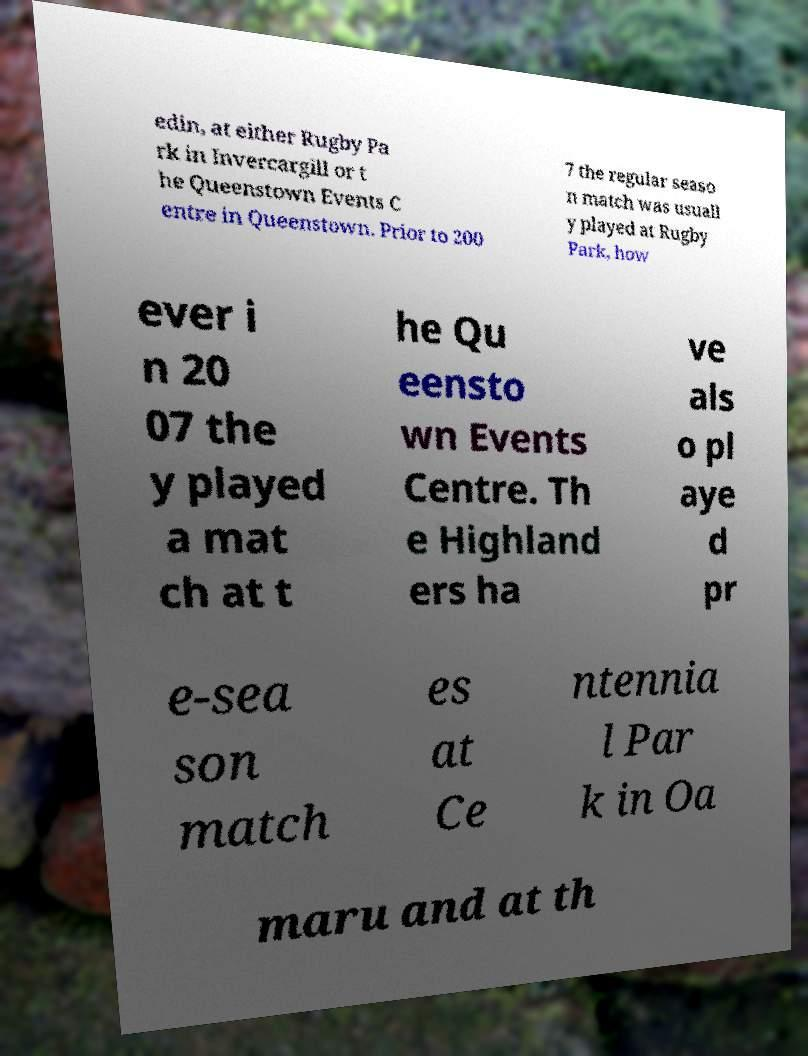Please identify and transcribe the text found in this image. edin, at either Rugby Pa rk in Invercargill or t he Queenstown Events C entre in Queenstown. Prior to 200 7 the regular seaso n match was usuall y played at Rugby Park, how ever i n 20 07 the y played a mat ch at t he Qu eensto wn Events Centre. Th e Highland ers ha ve als o pl aye d pr e-sea son match es at Ce ntennia l Par k in Oa maru and at th 